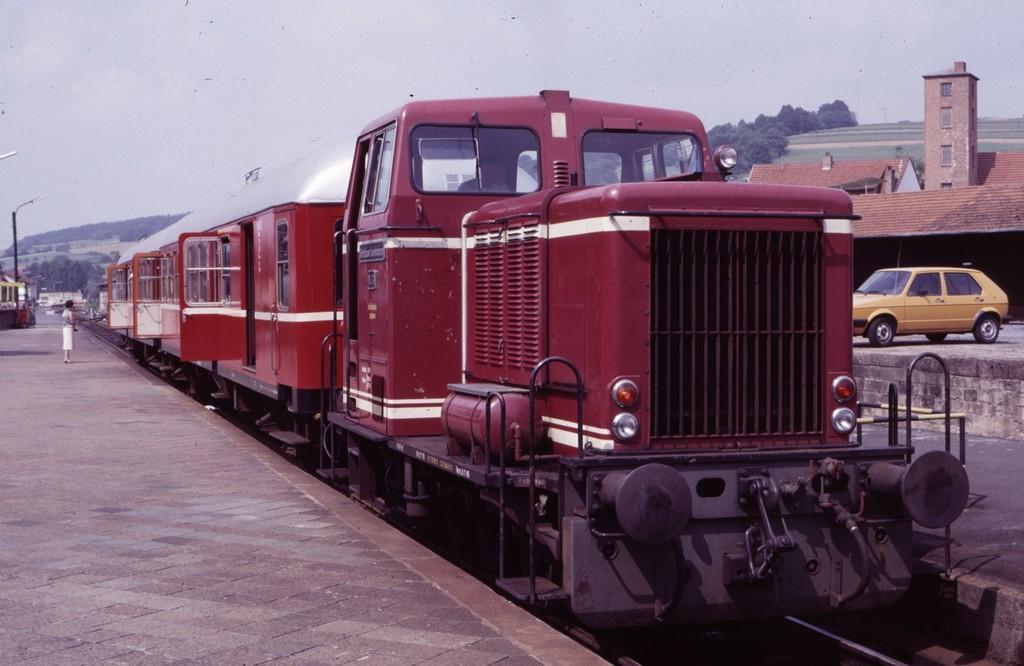Please provide a concise description of this image. In this image I can see a train in the centre and on the left side I can see one person is standing on the platform. I can also see a pole and two lights on the left side. On the right side of the image I can see a car, few buildings and number of trees. On the top side of this image I can see clouds and the sky. 